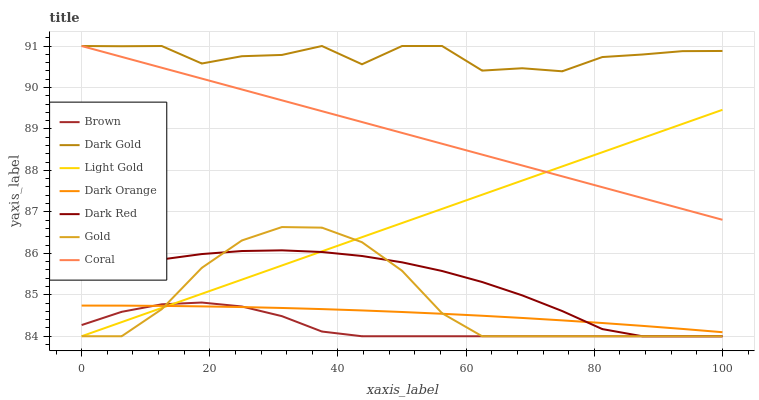Does Brown have the minimum area under the curve?
Answer yes or no. Yes. Does Dark Gold have the maximum area under the curve?
Answer yes or no. Yes. Does Gold have the minimum area under the curve?
Answer yes or no. No. Does Gold have the maximum area under the curve?
Answer yes or no. No. Is Light Gold the smoothest?
Answer yes or no. Yes. Is Dark Gold the roughest?
Answer yes or no. Yes. Is Gold the smoothest?
Answer yes or no. No. Is Gold the roughest?
Answer yes or no. No. Does Coral have the lowest value?
Answer yes or no. No. Does Dark Gold have the highest value?
Answer yes or no. Yes. Does Gold have the highest value?
Answer yes or no. No. Is Dark Red less than Coral?
Answer yes or no. Yes. Is Dark Gold greater than Dark Orange?
Answer yes or no. Yes. Does Dark Red intersect Light Gold?
Answer yes or no. Yes. Is Dark Red less than Light Gold?
Answer yes or no. No. Is Dark Red greater than Light Gold?
Answer yes or no. No. Does Dark Red intersect Coral?
Answer yes or no. No. 